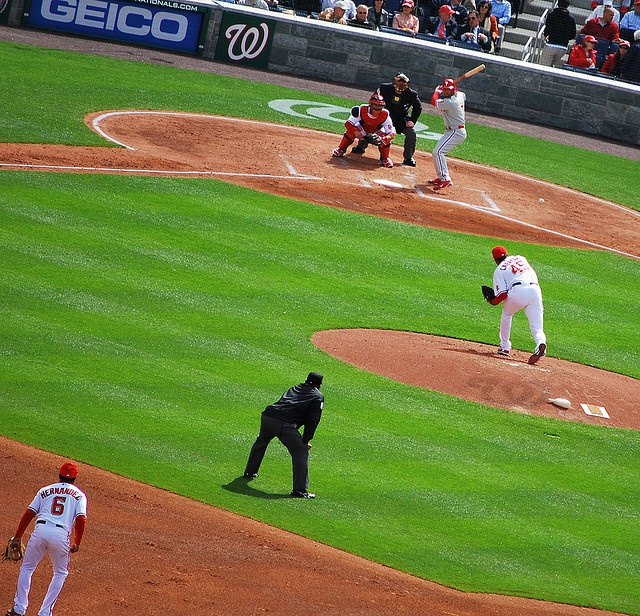Describe the objects in this image and their specific colors. I can see people in maroon, black, gray, white, and navy tones, people in maroon, darkgray, gray, and lavender tones, people in maroon, black, gray, and green tones, people in maroon, lavender, and darkgray tones, and people in maroon, darkgray, lightgray, brown, and gray tones in this image. 